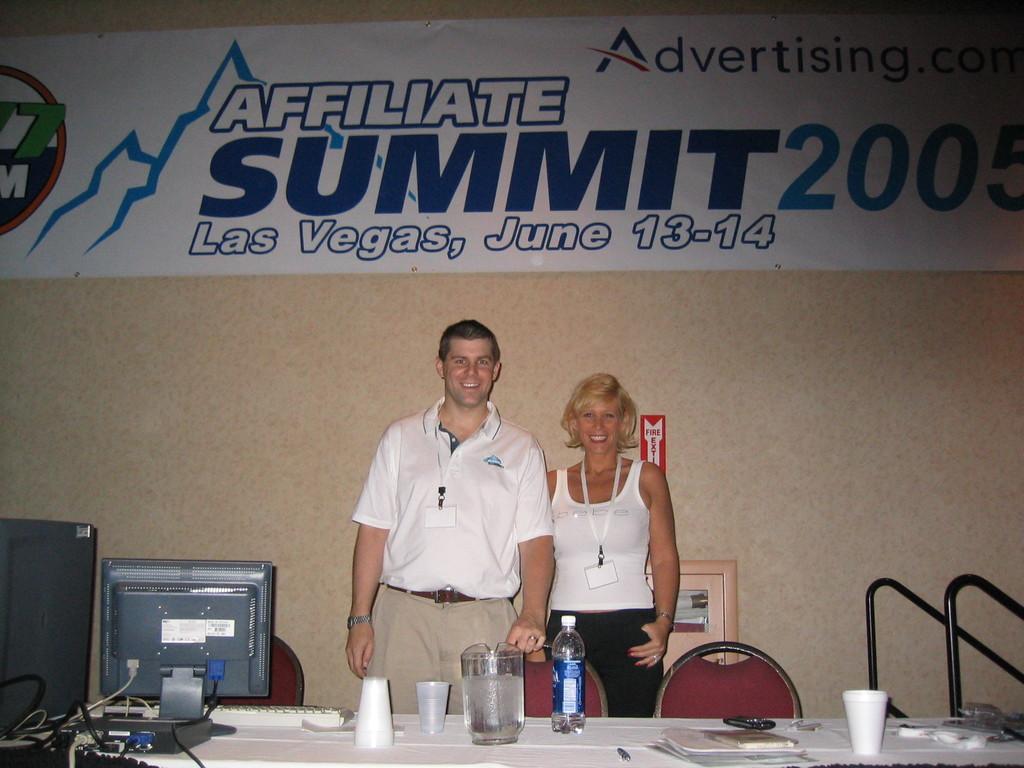Please provide a concise description of this image. It is a summit and there are two people standing in front of a table and posing for the photo and on the table there is a computer,a bottle and some glasses and books. In the background there is a wall and to the wall there is a big banner. 